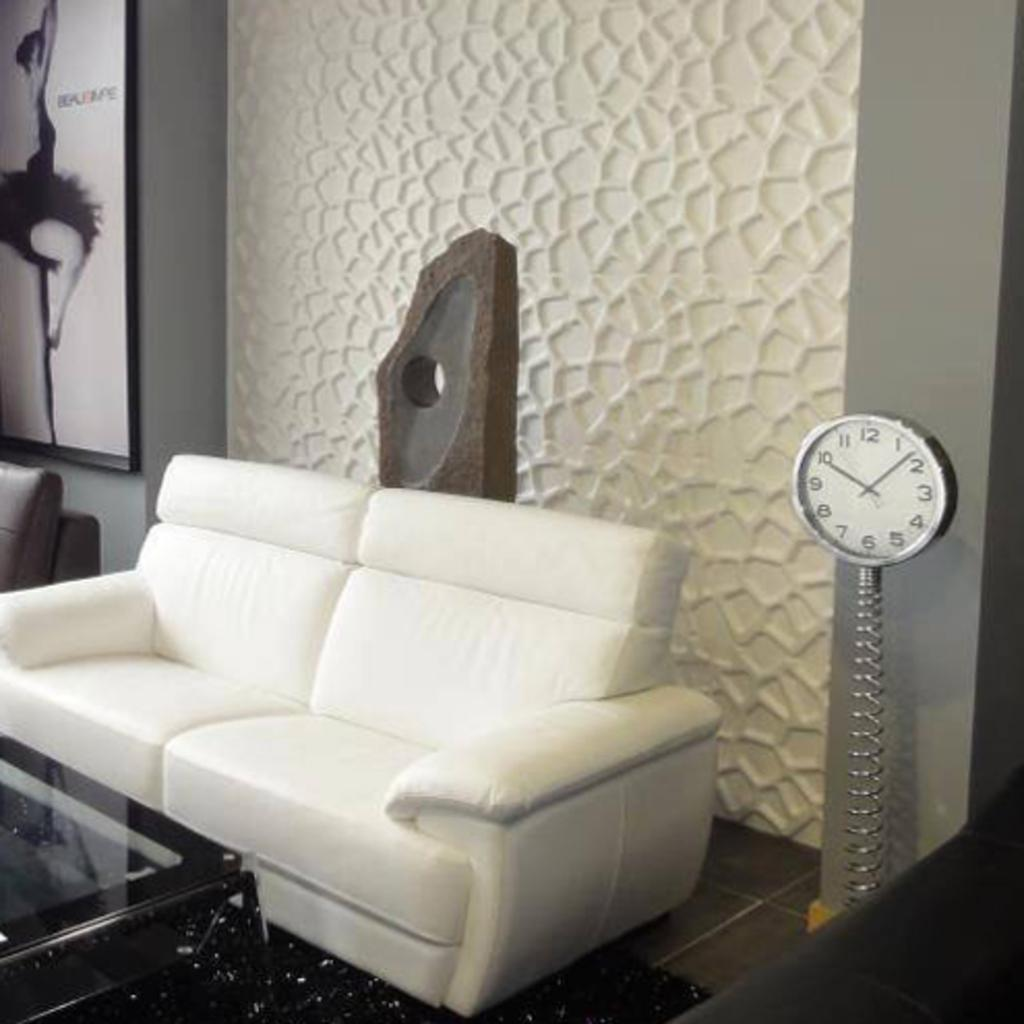<image>
Render a clear and concise summary of the photo. A white wall clock next to a couch that shows the time at approximately 10:08. 